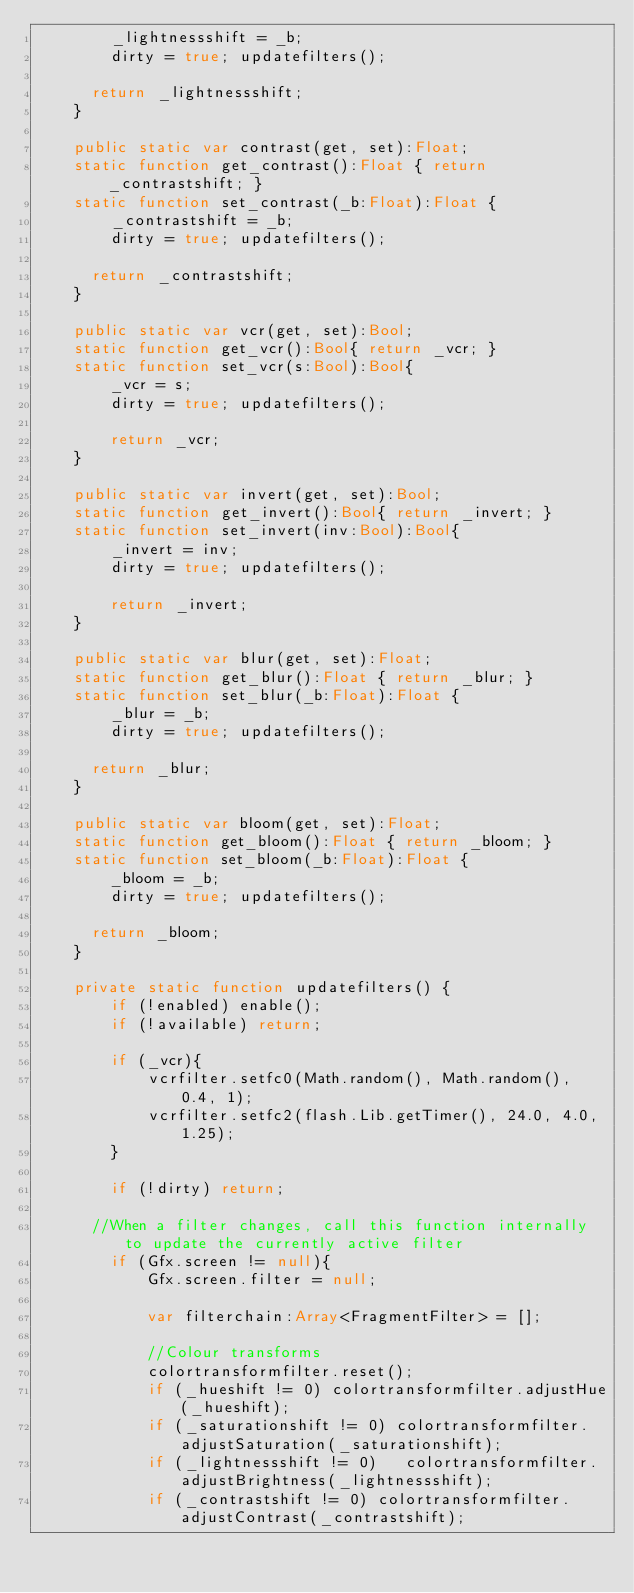Convert code to text. <code><loc_0><loc_0><loc_500><loc_500><_Haxe_>		_lightnessshift = _b;
		dirty = true; updatefilters();
		
	  return _lightnessshift;
	}
	
	public static var contrast(get, set):Float;
	static function get_contrast():Float { return _contrastshift; }
	static function set_contrast(_b:Float):Float {
		_contrastshift = _b;
		dirty = true; updatefilters();
		
	  return _contrastshift;
	}
	
	public static var vcr(get, set):Bool;
	static function get_vcr():Bool{ return _vcr; }
	static function set_vcr(s:Bool):Bool{
		_vcr = s;
		dirty = true; updatefilters();
		
		return _vcr;
	}
	
	public static var invert(get, set):Bool;
	static function get_invert():Bool{ return _invert; }
	static function set_invert(inv:Bool):Bool{
		_invert = inv;
		dirty = true; updatefilters();
		
		return _invert;
	}
	
	public static var blur(get, set):Float;
	static function get_blur():Float { return _blur; }
	static function set_blur(_b:Float):Float {
		_blur = _b;
		dirty = true; updatefilters();
		
	  return _blur;
	}
	
	public static var bloom(get, set):Float;
	static function get_bloom():Float { return _bloom; }
	static function set_bloom(_b:Float):Float {
		_bloom = _b;
		dirty = true; updatefilters();
		
	  return _bloom;
	}
	
	private static function updatefilters() {
		if (!enabled) enable();
		if (!available) return;
		
		if (_vcr){
			vcrfilter.setfc0(Math.random(), Math.random(), 0.4, 1);
			vcrfilter.setfc2(flash.Lib.getTimer(), 24.0, 4.0, 1.25);
		}
		
		if (!dirty) return;
		
	  //When a filter changes, call this function internally to update the currently active filter
		if (Gfx.screen != null){
			Gfx.screen.filter = null;
			
			var filterchain:Array<FragmentFilter> = [];
			
			//Colour transforms
			colortransformfilter.reset();
			if (_hueshift != 0)	colortransformfilter.adjustHue(_hueshift);
			if (_saturationshift != 0) colortransformfilter.adjustSaturation(_saturationshift);
			if (_lightnessshift != 0)	colortransformfilter.adjustBrightness(_lightnessshift);
			if (_contrastshift != 0) colortransformfilter.adjustContrast(_contrastshift);</code> 